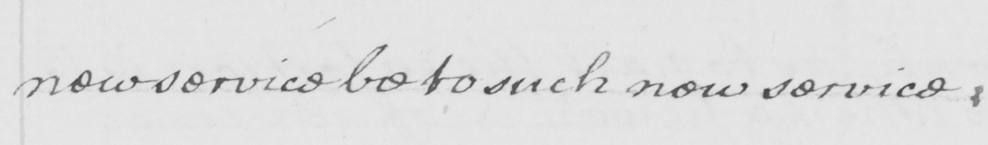Please provide the text content of this handwritten line. new service be to such new services . 